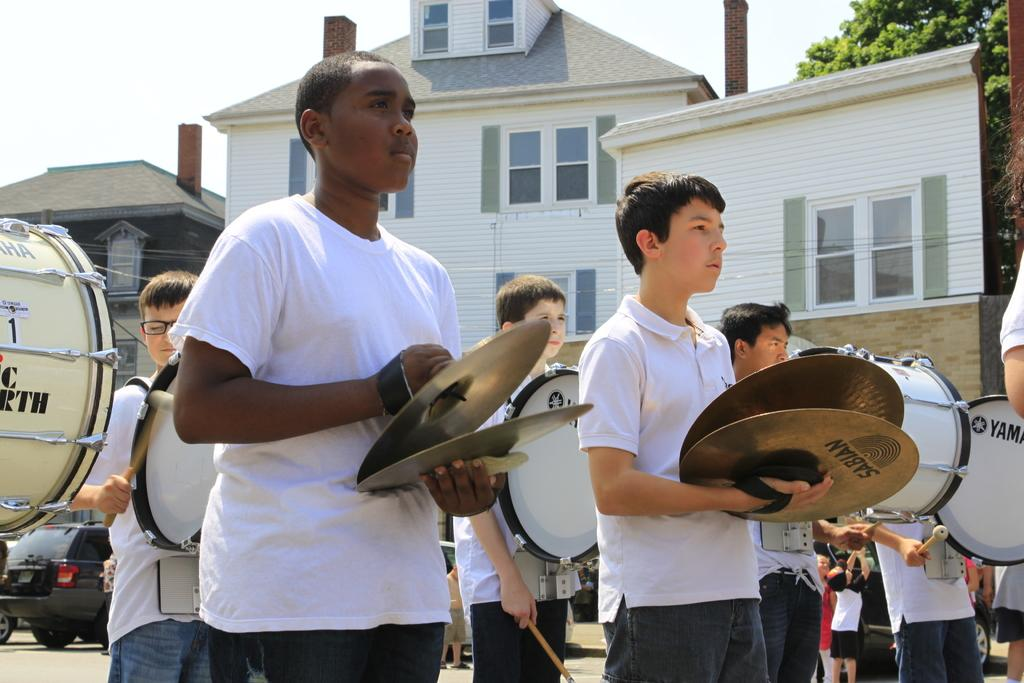<image>
Provide a brief description of the given image. A boy in a white polo shirt plays sabian cymbals. 